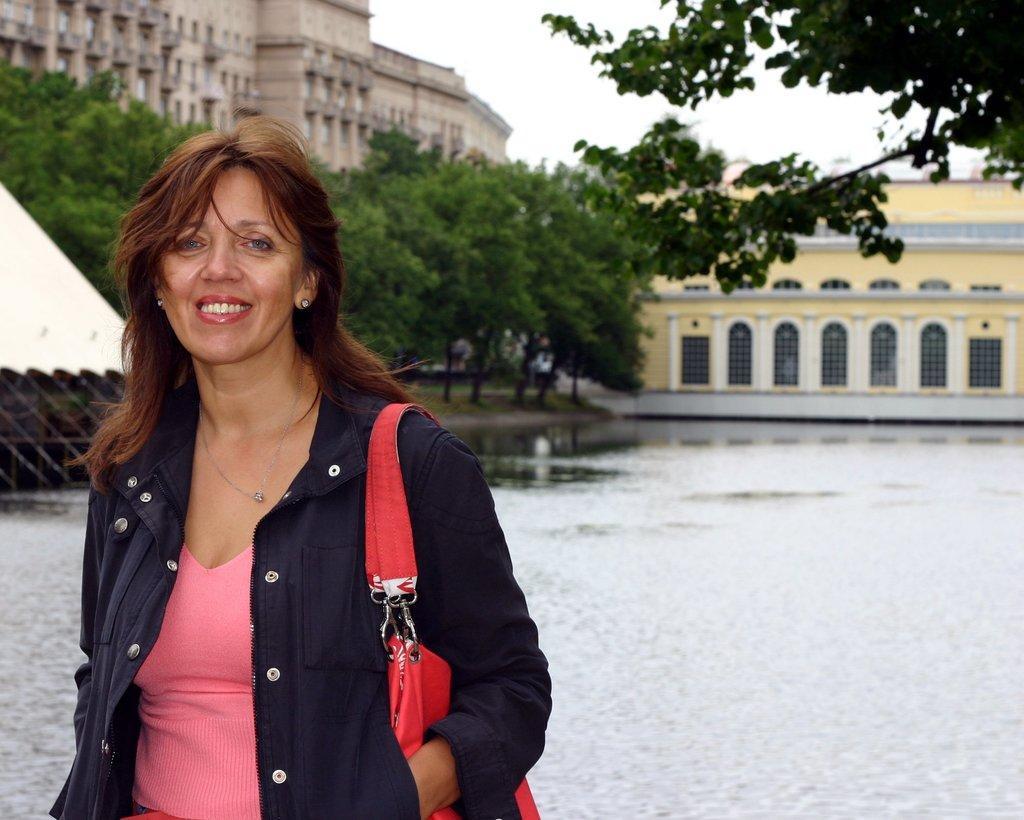Describe this image in one or two sentences. In this image there is a woman standing, she is wearing a bag, there is water towards the right of the image, there is an object towards the left of the image, there are trees, there is a tree towards the top of the image, there are buildings, there is the sky towards the top of the image. 